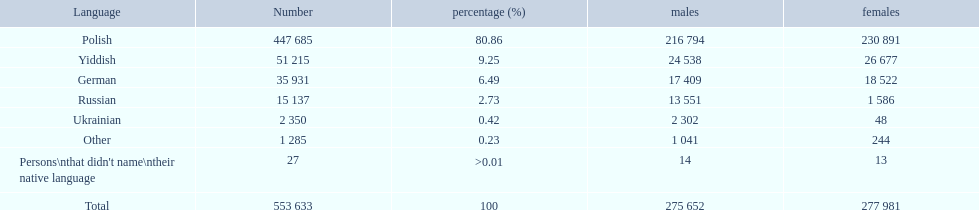What language makes a majority Polish. What the the total number of speakers? 553 633. 